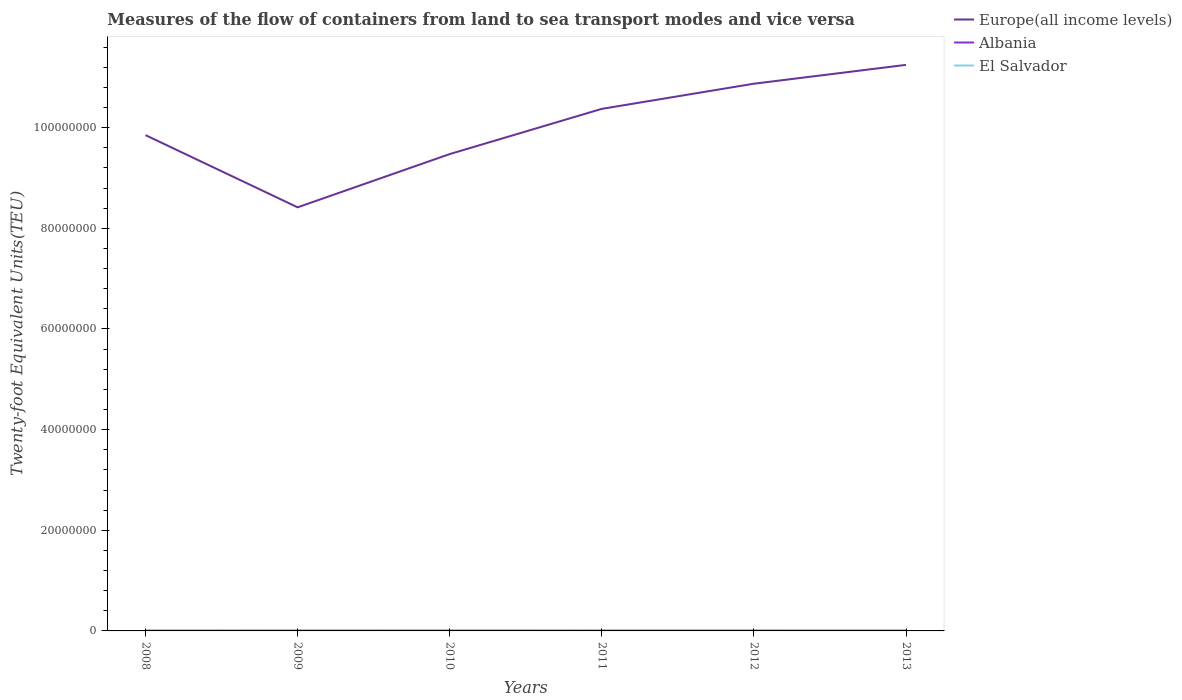Does the line corresponding to El Salvador intersect with the line corresponding to Europe(all income levels)?
Give a very brief answer. No. Is the number of lines equal to the number of legend labels?
Your answer should be compact. Yes. Across all years, what is the maximum container port traffic in El Salvador?
Make the answer very short. 1.26e+05. What is the total container port traffic in Albania in the graph?
Make the answer very short. -6887.02. What is the difference between the highest and the second highest container port traffic in Albania?
Your answer should be compact. 5.97e+04. Is the container port traffic in El Salvador strictly greater than the container port traffic in Albania over the years?
Provide a short and direct response. No. What is the difference between two consecutive major ticks on the Y-axis?
Provide a succinct answer. 2.00e+07. Are the values on the major ticks of Y-axis written in scientific E-notation?
Make the answer very short. No. Does the graph contain any zero values?
Give a very brief answer. No. How many legend labels are there?
Your answer should be very brief. 3. How are the legend labels stacked?
Make the answer very short. Vertical. What is the title of the graph?
Offer a terse response. Measures of the flow of containers from land to sea transport modes and vice versa. Does "Ireland" appear as one of the legend labels in the graph?
Give a very brief answer. No. What is the label or title of the X-axis?
Give a very brief answer. Years. What is the label or title of the Y-axis?
Your answer should be compact. Twenty-foot Equivalent Units(TEU). What is the Twenty-foot Equivalent Units(TEU) of Europe(all income levels) in 2008?
Your answer should be very brief. 9.85e+07. What is the Twenty-foot Equivalent Units(TEU) of Albania in 2008?
Your response must be concise. 4.68e+04. What is the Twenty-foot Equivalent Units(TEU) of El Salvador in 2008?
Give a very brief answer. 1.56e+05. What is the Twenty-foot Equivalent Units(TEU) in Europe(all income levels) in 2009?
Provide a short and direct response. 8.42e+07. What is the Twenty-foot Equivalent Units(TEU) of Albania in 2009?
Your response must be concise. 6.88e+04. What is the Twenty-foot Equivalent Units(TEU) in El Salvador in 2009?
Keep it short and to the point. 1.26e+05. What is the Twenty-foot Equivalent Units(TEU) in Europe(all income levels) in 2010?
Make the answer very short. 9.48e+07. What is the Twenty-foot Equivalent Units(TEU) of Albania in 2010?
Provide a short and direct response. 8.69e+04. What is the Twenty-foot Equivalent Units(TEU) of El Salvador in 2010?
Your response must be concise. 1.46e+05. What is the Twenty-foot Equivalent Units(TEU) of Europe(all income levels) in 2011?
Ensure brevity in your answer.  1.04e+08. What is the Twenty-foot Equivalent Units(TEU) in Albania in 2011?
Your answer should be compact. 9.18e+04. What is the Twenty-foot Equivalent Units(TEU) of El Salvador in 2011?
Keep it short and to the point. 1.61e+05. What is the Twenty-foot Equivalent Units(TEU) in Europe(all income levels) in 2012?
Keep it short and to the point. 1.09e+08. What is the Twenty-foot Equivalent Units(TEU) of Albania in 2012?
Provide a succinct answer. 9.87e+04. What is the Twenty-foot Equivalent Units(TEU) of El Salvador in 2012?
Offer a terse response. 1.61e+05. What is the Twenty-foot Equivalent Units(TEU) of Europe(all income levels) in 2013?
Offer a very short reply. 1.12e+08. What is the Twenty-foot Equivalent Units(TEU) of Albania in 2013?
Offer a terse response. 1.07e+05. What is the Twenty-foot Equivalent Units(TEU) in El Salvador in 2013?
Give a very brief answer. 1.81e+05. Across all years, what is the maximum Twenty-foot Equivalent Units(TEU) of Europe(all income levels)?
Your answer should be compact. 1.12e+08. Across all years, what is the maximum Twenty-foot Equivalent Units(TEU) in Albania?
Keep it short and to the point. 1.07e+05. Across all years, what is the maximum Twenty-foot Equivalent Units(TEU) in El Salvador?
Offer a very short reply. 1.81e+05. Across all years, what is the minimum Twenty-foot Equivalent Units(TEU) in Europe(all income levels)?
Ensure brevity in your answer.  8.42e+07. Across all years, what is the minimum Twenty-foot Equivalent Units(TEU) of Albania?
Your answer should be very brief. 4.68e+04. Across all years, what is the minimum Twenty-foot Equivalent Units(TEU) of El Salvador?
Ensure brevity in your answer.  1.26e+05. What is the total Twenty-foot Equivalent Units(TEU) in Europe(all income levels) in the graph?
Make the answer very short. 6.02e+08. What is the total Twenty-foot Equivalent Units(TEU) in Albania in the graph?
Provide a succinct answer. 5.00e+05. What is the total Twenty-foot Equivalent Units(TEU) in El Salvador in the graph?
Keep it short and to the point. 9.31e+05. What is the difference between the Twenty-foot Equivalent Units(TEU) in Europe(all income levels) in 2008 and that in 2009?
Make the answer very short. 1.43e+07. What is the difference between the Twenty-foot Equivalent Units(TEU) in Albania in 2008 and that in 2009?
Give a very brief answer. -2.20e+04. What is the difference between the Twenty-foot Equivalent Units(TEU) of El Salvador in 2008 and that in 2009?
Your answer should be compact. 3.00e+04. What is the difference between the Twenty-foot Equivalent Units(TEU) in Europe(all income levels) in 2008 and that in 2010?
Your answer should be very brief. 3.76e+06. What is the difference between the Twenty-foot Equivalent Units(TEU) in Albania in 2008 and that in 2010?
Your response must be concise. -4.01e+04. What is the difference between the Twenty-foot Equivalent Units(TEU) of El Salvador in 2008 and that in 2010?
Your answer should be very brief. 1.05e+04. What is the difference between the Twenty-foot Equivalent Units(TEU) in Europe(all income levels) in 2008 and that in 2011?
Your answer should be compact. -5.22e+06. What is the difference between the Twenty-foot Equivalent Units(TEU) of Albania in 2008 and that in 2011?
Your response must be concise. -4.50e+04. What is the difference between the Twenty-foot Equivalent Units(TEU) in El Salvador in 2008 and that in 2011?
Your answer should be very brief. -4877. What is the difference between the Twenty-foot Equivalent Units(TEU) of Europe(all income levels) in 2008 and that in 2012?
Make the answer very short. -1.02e+07. What is the difference between the Twenty-foot Equivalent Units(TEU) in Albania in 2008 and that in 2012?
Provide a succinct answer. -5.19e+04. What is the difference between the Twenty-foot Equivalent Units(TEU) in El Salvador in 2008 and that in 2012?
Give a very brief answer. -4677. What is the difference between the Twenty-foot Equivalent Units(TEU) of Europe(all income levels) in 2008 and that in 2013?
Your answer should be very brief. -1.40e+07. What is the difference between the Twenty-foot Equivalent Units(TEU) of Albania in 2008 and that in 2013?
Offer a terse response. -5.97e+04. What is the difference between the Twenty-foot Equivalent Units(TEU) of El Salvador in 2008 and that in 2013?
Give a very brief answer. -2.43e+04. What is the difference between the Twenty-foot Equivalent Units(TEU) of Europe(all income levels) in 2009 and that in 2010?
Provide a short and direct response. -1.06e+07. What is the difference between the Twenty-foot Equivalent Units(TEU) of Albania in 2009 and that in 2010?
Your answer should be very brief. -1.81e+04. What is the difference between the Twenty-foot Equivalent Units(TEU) in El Salvador in 2009 and that in 2010?
Your answer should be very brief. -1.94e+04. What is the difference between the Twenty-foot Equivalent Units(TEU) of Europe(all income levels) in 2009 and that in 2011?
Make the answer very short. -1.96e+07. What is the difference between the Twenty-foot Equivalent Units(TEU) of Albania in 2009 and that in 2011?
Provide a succinct answer. -2.30e+04. What is the difference between the Twenty-foot Equivalent Units(TEU) of El Salvador in 2009 and that in 2011?
Keep it short and to the point. -3.48e+04. What is the difference between the Twenty-foot Equivalent Units(TEU) in Europe(all income levels) in 2009 and that in 2012?
Your answer should be very brief. -2.46e+07. What is the difference between the Twenty-foot Equivalent Units(TEU) of Albania in 2009 and that in 2012?
Your answer should be compact. -2.99e+04. What is the difference between the Twenty-foot Equivalent Units(TEU) of El Salvador in 2009 and that in 2012?
Your answer should be compact. -3.46e+04. What is the difference between the Twenty-foot Equivalent Units(TEU) in Europe(all income levels) in 2009 and that in 2013?
Ensure brevity in your answer.  -2.83e+07. What is the difference between the Twenty-foot Equivalent Units(TEU) in Albania in 2009 and that in 2013?
Give a very brief answer. -3.77e+04. What is the difference between the Twenty-foot Equivalent Units(TEU) in El Salvador in 2009 and that in 2013?
Give a very brief answer. -5.42e+04. What is the difference between the Twenty-foot Equivalent Units(TEU) in Europe(all income levels) in 2010 and that in 2011?
Make the answer very short. -8.99e+06. What is the difference between the Twenty-foot Equivalent Units(TEU) of Albania in 2010 and that in 2011?
Your answer should be very brief. -4951.88. What is the difference between the Twenty-foot Equivalent Units(TEU) of El Salvador in 2010 and that in 2011?
Your answer should be compact. -1.54e+04. What is the difference between the Twenty-foot Equivalent Units(TEU) of Europe(all income levels) in 2010 and that in 2012?
Your answer should be compact. -1.40e+07. What is the difference between the Twenty-foot Equivalent Units(TEU) in Albania in 2010 and that in 2012?
Provide a short and direct response. -1.18e+04. What is the difference between the Twenty-foot Equivalent Units(TEU) of El Salvador in 2010 and that in 2012?
Make the answer very short. -1.52e+04. What is the difference between the Twenty-foot Equivalent Units(TEU) of Europe(all income levels) in 2010 and that in 2013?
Provide a succinct answer. -1.77e+07. What is the difference between the Twenty-foot Equivalent Units(TEU) in Albania in 2010 and that in 2013?
Ensure brevity in your answer.  -1.96e+04. What is the difference between the Twenty-foot Equivalent Units(TEU) of El Salvador in 2010 and that in 2013?
Make the answer very short. -3.48e+04. What is the difference between the Twenty-foot Equivalent Units(TEU) in Europe(all income levels) in 2011 and that in 2012?
Offer a very short reply. -5.00e+06. What is the difference between the Twenty-foot Equivalent Units(TEU) of Albania in 2011 and that in 2012?
Keep it short and to the point. -6887.02. What is the difference between the Twenty-foot Equivalent Units(TEU) in Europe(all income levels) in 2011 and that in 2013?
Ensure brevity in your answer.  -8.74e+06. What is the difference between the Twenty-foot Equivalent Units(TEU) of Albania in 2011 and that in 2013?
Offer a terse response. -1.47e+04. What is the difference between the Twenty-foot Equivalent Units(TEU) in El Salvador in 2011 and that in 2013?
Your answer should be very brief. -1.94e+04. What is the difference between the Twenty-foot Equivalent Units(TEU) of Europe(all income levels) in 2012 and that in 2013?
Provide a succinct answer. -3.74e+06. What is the difference between the Twenty-foot Equivalent Units(TEU) in Albania in 2012 and that in 2013?
Keep it short and to the point. -7798.4. What is the difference between the Twenty-foot Equivalent Units(TEU) of El Salvador in 2012 and that in 2013?
Offer a terse response. -1.96e+04. What is the difference between the Twenty-foot Equivalent Units(TEU) of Europe(all income levels) in 2008 and the Twenty-foot Equivalent Units(TEU) of Albania in 2009?
Your answer should be very brief. 9.85e+07. What is the difference between the Twenty-foot Equivalent Units(TEU) in Europe(all income levels) in 2008 and the Twenty-foot Equivalent Units(TEU) in El Salvador in 2009?
Keep it short and to the point. 9.84e+07. What is the difference between the Twenty-foot Equivalent Units(TEU) of Albania in 2008 and the Twenty-foot Equivalent Units(TEU) of El Salvador in 2009?
Ensure brevity in your answer.  -7.96e+04. What is the difference between the Twenty-foot Equivalent Units(TEU) in Europe(all income levels) in 2008 and the Twenty-foot Equivalent Units(TEU) in Albania in 2010?
Your answer should be compact. 9.84e+07. What is the difference between the Twenty-foot Equivalent Units(TEU) of Europe(all income levels) in 2008 and the Twenty-foot Equivalent Units(TEU) of El Salvador in 2010?
Keep it short and to the point. 9.84e+07. What is the difference between the Twenty-foot Equivalent Units(TEU) in Albania in 2008 and the Twenty-foot Equivalent Units(TEU) in El Salvador in 2010?
Provide a succinct answer. -9.90e+04. What is the difference between the Twenty-foot Equivalent Units(TEU) of Europe(all income levels) in 2008 and the Twenty-foot Equivalent Units(TEU) of Albania in 2011?
Provide a short and direct response. 9.84e+07. What is the difference between the Twenty-foot Equivalent Units(TEU) of Europe(all income levels) in 2008 and the Twenty-foot Equivalent Units(TEU) of El Salvador in 2011?
Your response must be concise. 9.84e+07. What is the difference between the Twenty-foot Equivalent Units(TEU) of Albania in 2008 and the Twenty-foot Equivalent Units(TEU) of El Salvador in 2011?
Keep it short and to the point. -1.14e+05. What is the difference between the Twenty-foot Equivalent Units(TEU) of Europe(all income levels) in 2008 and the Twenty-foot Equivalent Units(TEU) of Albania in 2012?
Your answer should be very brief. 9.84e+07. What is the difference between the Twenty-foot Equivalent Units(TEU) in Europe(all income levels) in 2008 and the Twenty-foot Equivalent Units(TEU) in El Salvador in 2012?
Offer a very short reply. 9.84e+07. What is the difference between the Twenty-foot Equivalent Units(TEU) of Albania in 2008 and the Twenty-foot Equivalent Units(TEU) of El Salvador in 2012?
Provide a succinct answer. -1.14e+05. What is the difference between the Twenty-foot Equivalent Units(TEU) in Europe(all income levels) in 2008 and the Twenty-foot Equivalent Units(TEU) in Albania in 2013?
Give a very brief answer. 9.84e+07. What is the difference between the Twenty-foot Equivalent Units(TEU) of Europe(all income levels) in 2008 and the Twenty-foot Equivalent Units(TEU) of El Salvador in 2013?
Your response must be concise. 9.83e+07. What is the difference between the Twenty-foot Equivalent Units(TEU) of Albania in 2008 and the Twenty-foot Equivalent Units(TEU) of El Salvador in 2013?
Ensure brevity in your answer.  -1.34e+05. What is the difference between the Twenty-foot Equivalent Units(TEU) in Europe(all income levels) in 2009 and the Twenty-foot Equivalent Units(TEU) in Albania in 2010?
Offer a very short reply. 8.41e+07. What is the difference between the Twenty-foot Equivalent Units(TEU) of Europe(all income levels) in 2009 and the Twenty-foot Equivalent Units(TEU) of El Salvador in 2010?
Offer a very short reply. 8.40e+07. What is the difference between the Twenty-foot Equivalent Units(TEU) in Albania in 2009 and the Twenty-foot Equivalent Units(TEU) in El Salvador in 2010?
Your response must be concise. -7.70e+04. What is the difference between the Twenty-foot Equivalent Units(TEU) of Europe(all income levels) in 2009 and the Twenty-foot Equivalent Units(TEU) of Albania in 2011?
Make the answer very short. 8.41e+07. What is the difference between the Twenty-foot Equivalent Units(TEU) in Europe(all income levels) in 2009 and the Twenty-foot Equivalent Units(TEU) in El Salvador in 2011?
Give a very brief answer. 8.40e+07. What is the difference between the Twenty-foot Equivalent Units(TEU) in Albania in 2009 and the Twenty-foot Equivalent Units(TEU) in El Salvador in 2011?
Give a very brief answer. -9.24e+04. What is the difference between the Twenty-foot Equivalent Units(TEU) in Europe(all income levels) in 2009 and the Twenty-foot Equivalent Units(TEU) in Albania in 2012?
Offer a terse response. 8.41e+07. What is the difference between the Twenty-foot Equivalent Units(TEU) of Europe(all income levels) in 2009 and the Twenty-foot Equivalent Units(TEU) of El Salvador in 2012?
Keep it short and to the point. 8.40e+07. What is the difference between the Twenty-foot Equivalent Units(TEU) of Albania in 2009 and the Twenty-foot Equivalent Units(TEU) of El Salvador in 2012?
Make the answer very short. -9.22e+04. What is the difference between the Twenty-foot Equivalent Units(TEU) of Europe(all income levels) in 2009 and the Twenty-foot Equivalent Units(TEU) of Albania in 2013?
Ensure brevity in your answer.  8.41e+07. What is the difference between the Twenty-foot Equivalent Units(TEU) in Europe(all income levels) in 2009 and the Twenty-foot Equivalent Units(TEU) in El Salvador in 2013?
Provide a short and direct response. 8.40e+07. What is the difference between the Twenty-foot Equivalent Units(TEU) of Albania in 2009 and the Twenty-foot Equivalent Units(TEU) of El Salvador in 2013?
Ensure brevity in your answer.  -1.12e+05. What is the difference between the Twenty-foot Equivalent Units(TEU) in Europe(all income levels) in 2010 and the Twenty-foot Equivalent Units(TEU) in Albania in 2011?
Your answer should be compact. 9.47e+07. What is the difference between the Twenty-foot Equivalent Units(TEU) of Europe(all income levels) in 2010 and the Twenty-foot Equivalent Units(TEU) of El Salvador in 2011?
Provide a short and direct response. 9.46e+07. What is the difference between the Twenty-foot Equivalent Units(TEU) of Albania in 2010 and the Twenty-foot Equivalent Units(TEU) of El Salvador in 2011?
Offer a very short reply. -7.43e+04. What is the difference between the Twenty-foot Equivalent Units(TEU) of Europe(all income levels) in 2010 and the Twenty-foot Equivalent Units(TEU) of Albania in 2012?
Your response must be concise. 9.47e+07. What is the difference between the Twenty-foot Equivalent Units(TEU) of Europe(all income levels) in 2010 and the Twenty-foot Equivalent Units(TEU) of El Salvador in 2012?
Provide a short and direct response. 9.46e+07. What is the difference between the Twenty-foot Equivalent Units(TEU) of Albania in 2010 and the Twenty-foot Equivalent Units(TEU) of El Salvador in 2012?
Offer a very short reply. -7.41e+04. What is the difference between the Twenty-foot Equivalent Units(TEU) of Europe(all income levels) in 2010 and the Twenty-foot Equivalent Units(TEU) of Albania in 2013?
Your answer should be very brief. 9.47e+07. What is the difference between the Twenty-foot Equivalent Units(TEU) in Europe(all income levels) in 2010 and the Twenty-foot Equivalent Units(TEU) in El Salvador in 2013?
Your answer should be compact. 9.46e+07. What is the difference between the Twenty-foot Equivalent Units(TEU) of Albania in 2010 and the Twenty-foot Equivalent Units(TEU) of El Salvador in 2013?
Provide a succinct answer. -9.37e+04. What is the difference between the Twenty-foot Equivalent Units(TEU) of Europe(all income levels) in 2011 and the Twenty-foot Equivalent Units(TEU) of Albania in 2012?
Your answer should be compact. 1.04e+08. What is the difference between the Twenty-foot Equivalent Units(TEU) of Europe(all income levels) in 2011 and the Twenty-foot Equivalent Units(TEU) of El Salvador in 2012?
Ensure brevity in your answer.  1.04e+08. What is the difference between the Twenty-foot Equivalent Units(TEU) of Albania in 2011 and the Twenty-foot Equivalent Units(TEU) of El Salvador in 2012?
Make the answer very short. -6.92e+04. What is the difference between the Twenty-foot Equivalent Units(TEU) of Europe(all income levels) in 2011 and the Twenty-foot Equivalent Units(TEU) of Albania in 2013?
Provide a succinct answer. 1.04e+08. What is the difference between the Twenty-foot Equivalent Units(TEU) in Europe(all income levels) in 2011 and the Twenty-foot Equivalent Units(TEU) in El Salvador in 2013?
Provide a short and direct response. 1.04e+08. What is the difference between the Twenty-foot Equivalent Units(TEU) of Albania in 2011 and the Twenty-foot Equivalent Units(TEU) of El Salvador in 2013?
Keep it short and to the point. -8.88e+04. What is the difference between the Twenty-foot Equivalent Units(TEU) of Europe(all income levels) in 2012 and the Twenty-foot Equivalent Units(TEU) of Albania in 2013?
Give a very brief answer. 1.09e+08. What is the difference between the Twenty-foot Equivalent Units(TEU) in Europe(all income levels) in 2012 and the Twenty-foot Equivalent Units(TEU) in El Salvador in 2013?
Your response must be concise. 1.09e+08. What is the difference between the Twenty-foot Equivalent Units(TEU) in Albania in 2012 and the Twenty-foot Equivalent Units(TEU) in El Salvador in 2013?
Provide a short and direct response. -8.19e+04. What is the average Twenty-foot Equivalent Units(TEU) of Europe(all income levels) per year?
Make the answer very short. 1.00e+08. What is the average Twenty-foot Equivalent Units(TEU) in Albania per year?
Ensure brevity in your answer.  8.33e+04. What is the average Twenty-foot Equivalent Units(TEU) of El Salvador per year?
Make the answer very short. 1.55e+05. In the year 2008, what is the difference between the Twenty-foot Equivalent Units(TEU) in Europe(all income levels) and Twenty-foot Equivalent Units(TEU) in Albania?
Make the answer very short. 9.85e+07. In the year 2008, what is the difference between the Twenty-foot Equivalent Units(TEU) of Europe(all income levels) and Twenty-foot Equivalent Units(TEU) of El Salvador?
Make the answer very short. 9.84e+07. In the year 2008, what is the difference between the Twenty-foot Equivalent Units(TEU) in Albania and Twenty-foot Equivalent Units(TEU) in El Salvador?
Give a very brief answer. -1.10e+05. In the year 2009, what is the difference between the Twenty-foot Equivalent Units(TEU) of Europe(all income levels) and Twenty-foot Equivalent Units(TEU) of Albania?
Make the answer very short. 8.41e+07. In the year 2009, what is the difference between the Twenty-foot Equivalent Units(TEU) of Europe(all income levels) and Twenty-foot Equivalent Units(TEU) of El Salvador?
Make the answer very short. 8.41e+07. In the year 2009, what is the difference between the Twenty-foot Equivalent Units(TEU) of Albania and Twenty-foot Equivalent Units(TEU) of El Salvador?
Provide a short and direct response. -5.76e+04. In the year 2010, what is the difference between the Twenty-foot Equivalent Units(TEU) in Europe(all income levels) and Twenty-foot Equivalent Units(TEU) in Albania?
Make the answer very short. 9.47e+07. In the year 2010, what is the difference between the Twenty-foot Equivalent Units(TEU) of Europe(all income levels) and Twenty-foot Equivalent Units(TEU) of El Salvador?
Ensure brevity in your answer.  9.46e+07. In the year 2010, what is the difference between the Twenty-foot Equivalent Units(TEU) in Albania and Twenty-foot Equivalent Units(TEU) in El Salvador?
Ensure brevity in your answer.  -5.89e+04. In the year 2011, what is the difference between the Twenty-foot Equivalent Units(TEU) of Europe(all income levels) and Twenty-foot Equivalent Units(TEU) of Albania?
Provide a succinct answer. 1.04e+08. In the year 2011, what is the difference between the Twenty-foot Equivalent Units(TEU) in Europe(all income levels) and Twenty-foot Equivalent Units(TEU) in El Salvador?
Provide a succinct answer. 1.04e+08. In the year 2011, what is the difference between the Twenty-foot Equivalent Units(TEU) of Albania and Twenty-foot Equivalent Units(TEU) of El Salvador?
Your answer should be compact. -6.94e+04. In the year 2012, what is the difference between the Twenty-foot Equivalent Units(TEU) in Europe(all income levels) and Twenty-foot Equivalent Units(TEU) in Albania?
Your answer should be very brief. 1.09e+08. In the year 2012, what is the difference between the Twenty-foot Equivalent Units(TEU) of Europe(all income levels) and Twenty-foot Equivalent Units(TEU) of El Salvador?
Provide a short and direct response. 1.09e+08. In the year 2012, what is the difference between the Twenty-foot Equivalent Units(TEU) in Albania and Twenty-foot Equivalent Units(TEU) in El Salvador?
Make the answer very short. -6.23e+04. In the year 2013, what is the difference between the Twenty-foot Equivalent Units(TEU) of Europe(all income levels) and Twenty-foot Equivalent Units(TEU) of Albania?
Your response must be concise. 1.12e+08. In the year 2013, what is the difference between the Twenty-foot Equivalent Units(TEU) of Europe(all income levels) and Twenty-foot Equivalent Units(TEU) of El Salvador?
Make the answer very short. 1.12e+08. In the year 2013, what is the difference between the Twenty-foot Equivalent Units(TEU) in Albania and Twenty-foot Equivalent Units(TEU) in El Salvador?
Your answer should be very brief. -7.41e+04. What is the ratio of the Twenty-foot Equivalent Units(TEU) of Europe(all income levels) in 2008 to that in 2009?
Your response must be concise. 1.17. What is the ratio of the Twenty-foot Equivalent Units(TEU) in Albania in 2008 to that in 2009?
Offer a very short reply. 0.68. What is the ratio of the Twenty-foot Equivalent Units(TEU) of El Salvador in 2008 to that in 2009?
Keep it short and to the point. 1.24. What is the ratio of the Twenty-foot Equivalent Units(TEU) of Europe(all income levels) in 2008 to that in 2010?
Offer a very short reply. 1.04. What is the ratio of the Twenty-foot Equivalent Units(TEU) in Albania in 2008 to that in 2010?
Your answer should be very brief. 0.54. What is the ratio of the Twenty-foot Equivalent Units(TEU) in El Salvador in 2008 to that in 2010?
Provide a succinct answer. 1.07. What is the ratio of the Twenty-foot Equivalent Units(TEU) in Europe(all income levels) in 2008 to that in 2011?
Provide a succinct answer. 0.95. What is the ratio of the Twenty-foot Equivalent Units(TEU) of Albania in 2008 to that in 2011?
Keep it short and to the point. 0.51. What is the ratio of the Twenty-foot Equivalent Units(TEU) in El Salvador in 2008 to that in 2011?
Your response must be concise. 0.97. What is the ratio of the Twenty-foot Equivalent Units(TEU) of Europe(all income levels) in 2008 to that in 2012?
Make the answer very short. 0.91. What is the ratio of the Twenty-foot Equivalent Units(TEU) in Albania in 2008 to that in 2012?
Your response must be concise. 0.47. What is the ratio of the Twenty-foot Equivalent Units(TEU) of El Salvador in 2008 to that in 2012?
Make the answer very short. 0.97. What is the ratio of the Twenty-foot Equivalent Units(TEU) in Europe(all income levels) in 2008 to that in 2013?
Provide a succinct answer. 0.88. What is the ratio of the Twenty-foot Equivalent Units(TEU) of Albania in 2008 to that in 2013?
Keep it short and to the point. 0.44. What is the ratio of the Twenty-foot Equivalent Units(TEU) of El Salvador in 2008 to that in 2013?
Offer a terse response. 0.87. What is the ratio of the Twenty-foot Equivalent Units(TEU) of Europe(all income levels) in 2009 to that in 2010?
Give a very brief answer. 0.89. What is the ratio of the Twenty-foot Equivalent Units(TEU) of Albania in 2009 to that in 2010?
Your response must be concise. 0.79. What is the ratio of the Twenty-foot Equivalent Units(TEU) in El Salvador in 2009 to that in 2010?
Make the answer very short. 0.87. What is the ratio of the Twenty-foot Equivalent Units(TEU) in Europe(all income levels) in 2009 to that in 2011?
Give a very brief answer. 0.81. What is the ratio of the Twenty-foot Equivalent Units(TEU) of Albania in 2009 to that in 2011?
Provide a succinct answer. 0.75. What is the ratio of the Twenty-foot Equivalent Units(TEU) of El Salvador in 2009 to that in 2011?
Give a very brief answer. 0.78. What is the ratio of the Twenty-foot Equivalent Units(TEU) in Europe(all income levels) in 2009 to that in 2012?
Make the answer very short. 0.77. What is the ratio of the Twenty-foot Equivalent Units(TEU) in Albania in 2009 to that in 2012?
Provide a succinct answer. 0.7. What is the ratio of the Twenty-foot Equivalent Units(TEU) in El Salvador in 2009 to that in 2012?
Keep it short and to the point. 0.78. What is the ratio of the Twenty-foot Equivalent Units(TEU) in Europe(all income levels) in 2009 to that in 2013?
Give a very brief answer. 0.75. What is the ratio of the Twenty-foot Equivalent Units(TEU) of Albania in 2009 to that in 2013?
Make the answer very short. 0.65. What is the ratio of the Twenty-foot Equivalent Units(TEU) of El Salvador in 2009 to that in 2013?
Keep it short and to the point. 0.7. What is the ratio of the Twenty-foot Equivalent Units(TEU) in Europe(all income levels) in 2010 to that in 2011?
Provide a succinct answer. 0.91. What is the ratio of the Twenty-foot Equivalent Units(TEU) in Albania in 2010 to that in 2011?
Offer a very short reply. 0.95. What is the ratio of the Twenty-foot Equivalent Units(TEU) in El Salvador in 2010 to that in 2011?
Make the answer very short. 0.9. What is the ratio of the Twenty-foot Equivalent Units(TEU) in Europe(all income levels) in 2010 to that in 2012?
Give a very brief answer. 0.87. What is the ratio of the Twenty-foot Equivalent Units(TEU) of Albania in 2010 to that in 2012?
Ensure brevity in your answer.  0.88. What is the ratio of the Twenty-foot Equivalent Units(TEU) of El Salvador in 2010 to that in 2012?
Offer a terse response. 0.91. What is the ratio of the Twenty-foot Equivalent Units(TEU) of Europe(all income levels) in 2010 to that in 2013?
Offer a very short reply. 0.84. What is the ratio of the Twenty-foot Equivalent Units(TEU) of Albania in 2010 to that in 2013?
Ensure brevity in your answer.  0.82. What is the ratio of the Twenty-foot Equivalent Units(TEU) of El Salvador in 2010 to that in 2013?
Provide a succinct answer. 0.81. What is the ratio of the Twenty-foot Equivalent Units(TEU) in Europe(all income levels) in 2011 to that in 2012?
Offer a very short reply. 0.95. What is the ratio of the Twenty-foot Equivalent Units(TEU) of Albania in 2011 to that in 2012?
Keep it short and to the point. 0.93. What is the ratio of the Twenty-foot Equivalent Units(TEU) of El Salvador in 2011 to that in 2012?
Make the answer very short. 1. What is the ratio of the Twenty-foot Equivalent Units(TEU) in Europe(all income levels) in 2011 to that in 2013?
Give a very brief answer. 0.92. What is the ratio of the Twenty-foot Equivalent Units(TEU) of Albania in 2011 to that in 2013?
Provide a short and direct response. 0.86. What is the ratio of the Twenty-foot Equivalent Units(TEU) of El Salvador in 2011 to that in 2013?
Ensure brevity in your answer.  0.89. What is the ratio of the Twenty-foot Equivalent Units(TEU) of Europe(all income levels) in 2012 to that in 2013?
Offer a terse response. 0.97. What is the ratio of the Twenty-foot Equivalent Units(TEU) of Albania in 2012 to that in 2013?
Offer a very short reply. 0.93. What is the ratio of the Twenty-foot Equivalent Units(TEU) of El Salvador in 2012 to that in 2013?
Your answer should be compact. 0.89. What is the difference between the highest and the second highest Twenty-foot Equivalent Units(TEU) in Europe(all income levels)?
Provide a short and direct response. 3.74e+06. What is the difference between the highest and the second highest Twenty-foot Equivalent Units(TEU) in Albania?
Keep it short and to the point. 7798.4. What is the difference between the highest and the second highest Twenty-foot Equivalent Units(TEU) in El Salvador?
Offer a very short reply. 1.94e+04. What is the difference between the highest and the lowest Twenty-foot Equivalent Units(TEU) of Europe(all income levels)?
Offer a very short reply. 2.83e+07. What is the difference between the highest and the lowest Twenty-foot Equivalent Units(TEU) of Albania?
Provide a succinct answer. 5.97e+04. What is the difference between the highest and the lowest Twenty-foot Equivalent Units(TEU) in El Salvador?
Your answer should be very brief. 5.42e+04. 